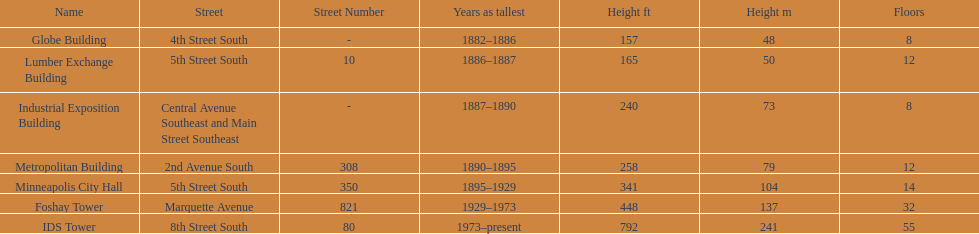Parse the full table. {'header': ['Name', 'Street', 'Street Number', 'Years as tallest', 'Height ft', 'Height m', 'Floors'], 'rows': [['Globe Building', '4th Street South', '-', '1882–1886', '157', '48', '8'], ['Lumber Exchange Building', '5th Street South', '10', '1886–1887', '165', '50', '12'], ['Industrial Exposition Building', 'Central Avenue Southeast and Main Street Southeast', '-', '1887–1890', '240', '73', '8'], ['Metropolitan Building', '2nd Avenue South', '308', '1890–1895', '258', '79', '12'], ['Minneapolis City Hall', '5th Street South', '350', '1895–1929', '341', '104', '14'], ['Foshay Tower', 'Marquette Avenue', '821', '1929–1973', '448', '137', '32'], ['IDS Tower', '8th Street South', '80', '1973–present', '792', '241', '55']]} What was the first building named as the tallest? Globe Building. 